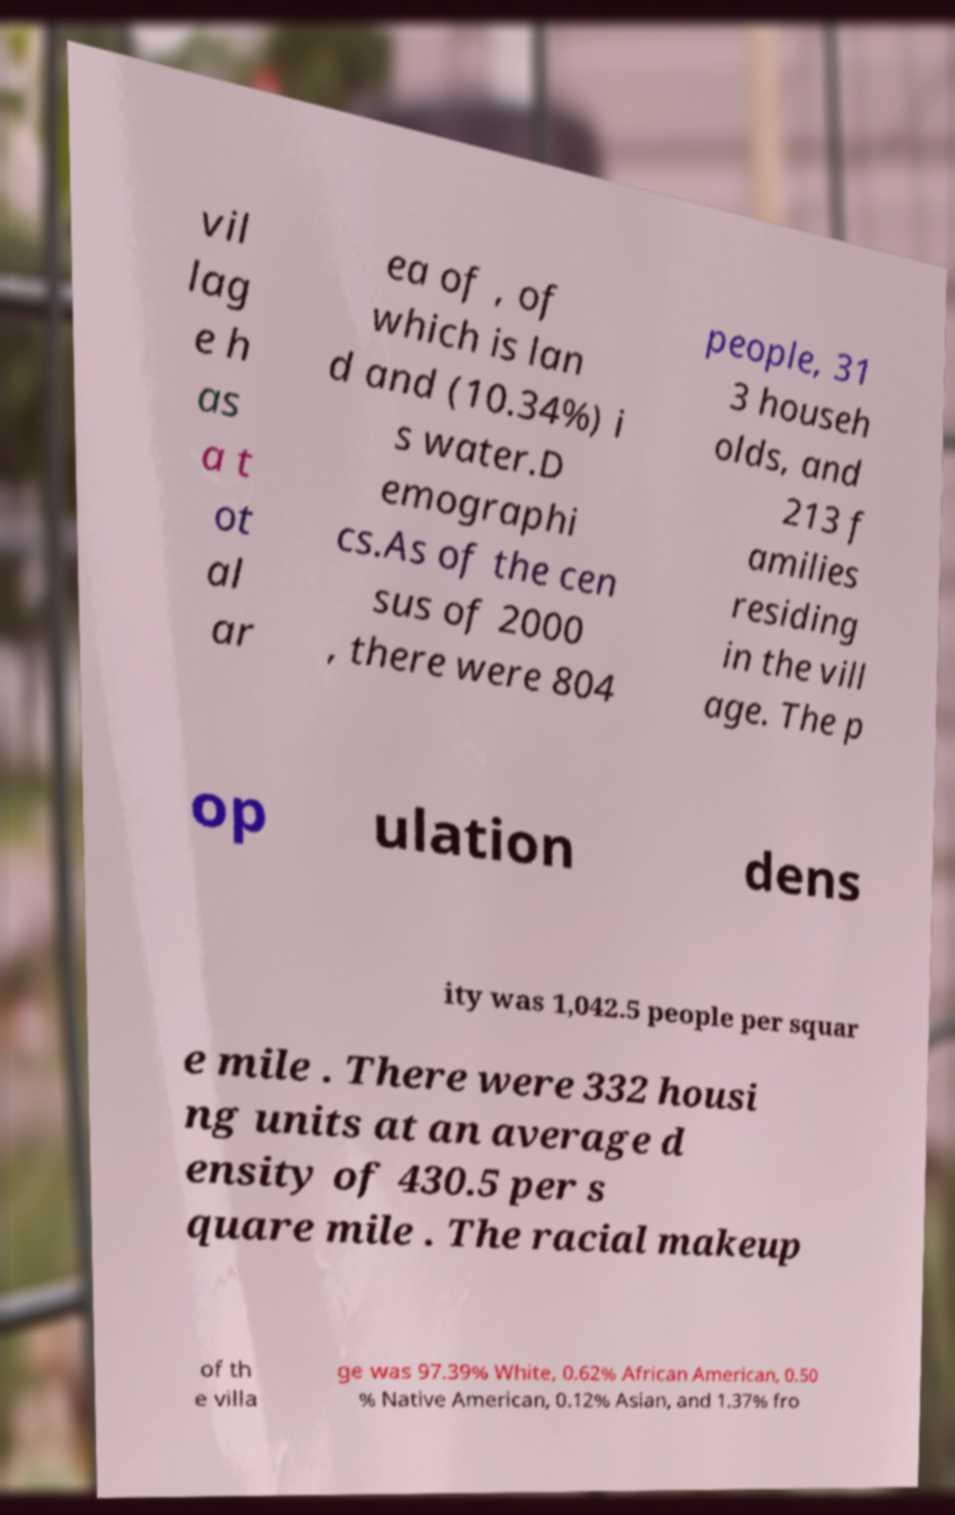There's text embedded in this image that I need extracted. Can you transcribe it verbatim? vil lag e h as a t ot al ar ea of , of which is lan d and (10.34%) i s water.D emographi cs.As of the cen sus of 2000 , there were 804 people, 31 3 househ olds, and 213 f amilies residing in the vill age. The p op ulation dens ity was 1,042.5 people per squar e mile . There were 332 housi ng units at an average d ensity of 430.5 per s quare mile . The racial makeup of th e villa ge was 97.39% White, 0.62% African American, 0.50 % Native American, 0.12% Asian, and 1.37% fro 